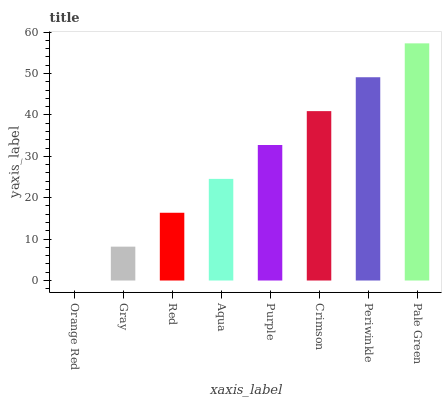Is Orange Red the minimum?
Answer yes or no. Yes. Is Pale Green the maximum?
Answer yes or no. Yes. Is Gray the minimum?
Answer yes or no. No. Is Gray the maximum?
Answer yes or no. No. Is Gray greater than Orange Red?
Answer yes or no. Yes. Is Orange Red less than Gray?
Answer yes or no. Yes. Is Orange Red greater than Gray?
Answer yes or no. No. Is Gray less than Orange Red?
Answer yes or no. No. Is Purple the high median?
Answer yes or no. Yes. Is Aqua the low median?
Answer yes or no. Yes. Is Pale Green the high median?
Answer yes or no. No. Is Orange Red the low median?
Answer yes or no. No. 